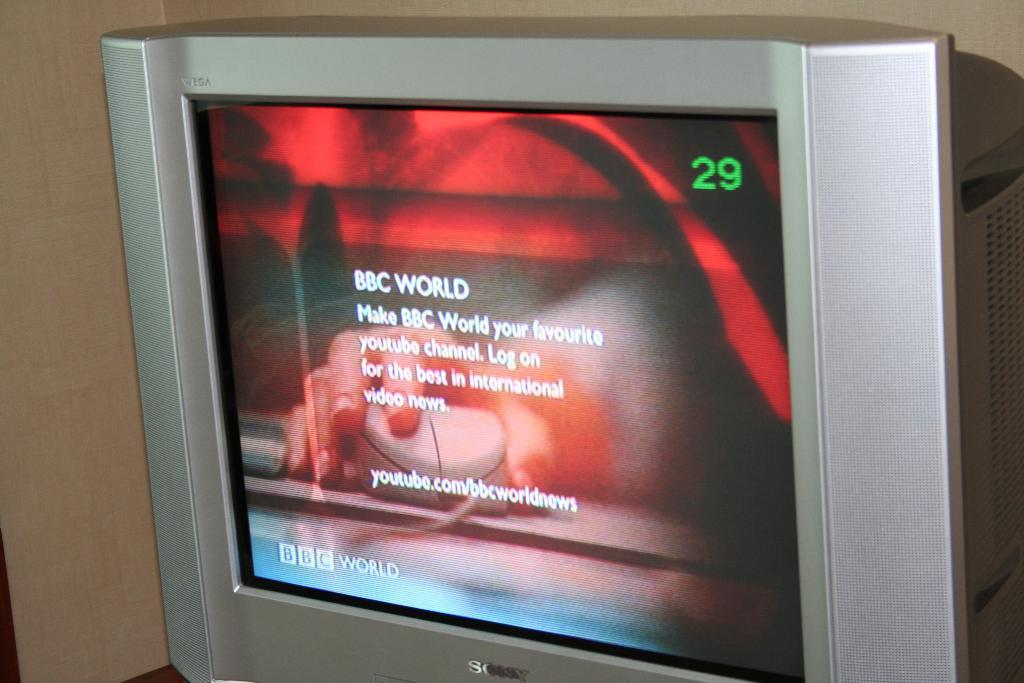<image>
Create a compact narrative representing the image presented. A silver TV says BBC World on the screen and is set to channel 29. 